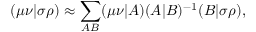<formula> <loc_0><loc_0><loc_500><loc_500>( \mu \nu | \sigma \rho ) \approx \sum _ { A B } ( \mu \nu | A ) ( A | B ) ^ { - 1 } ( B | \sigma \rho ) ,</formula> 